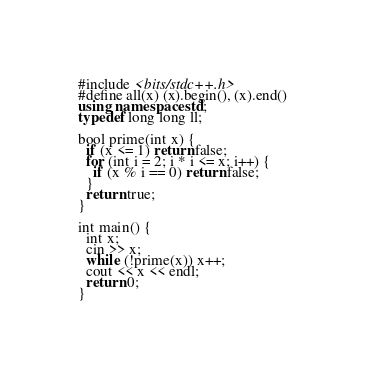Convert code to text. <code><loc_0><loc_0><loc_500><loc_500><_C++_>#include <bits/stdc++.h>
#define all(x) (x).begin(), (x).end()
using namespace std;
typedef long long ll;

bool prime(int x) {
  if (x <= 1) return false;
  for (int i = 2; i * i <= x; i++) {
    if (x % i == 0) return false;
  }
  return true;
}

int main() {
  int x;
  cin >> x;
  while (!prime(x)) x++;
  cout << x << endl;
  return 0;
}</code> 